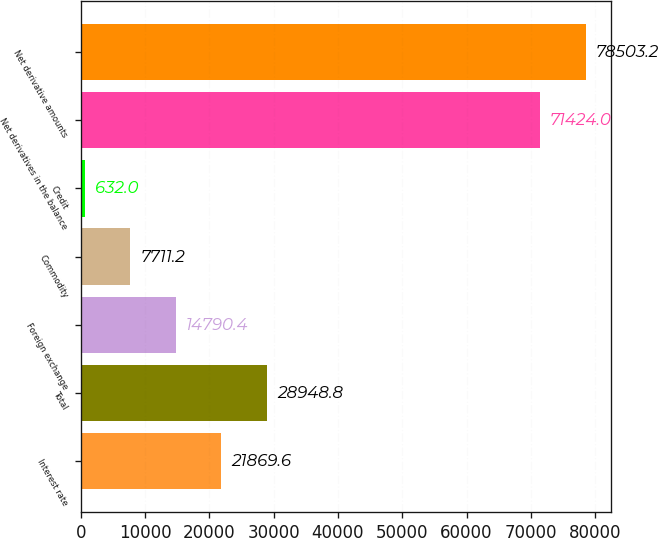Convert chart to OTSL. <chart><loc_0><loc_0><loc_500><loc_500><bar_chart><fcel>Interest rate<fcel>Total<fcel>Foreign exchange<fcel>Commodity<fcel>Credit<fcel>Net derivatives in the balance<fcel>Net derivative amounts<nl><fcel>21869.6<fcel>28948.8<fcel>14790.4<fcel>7711.2<fcel>632<fcel>71424<fcel>78503.2<nl></chart> 